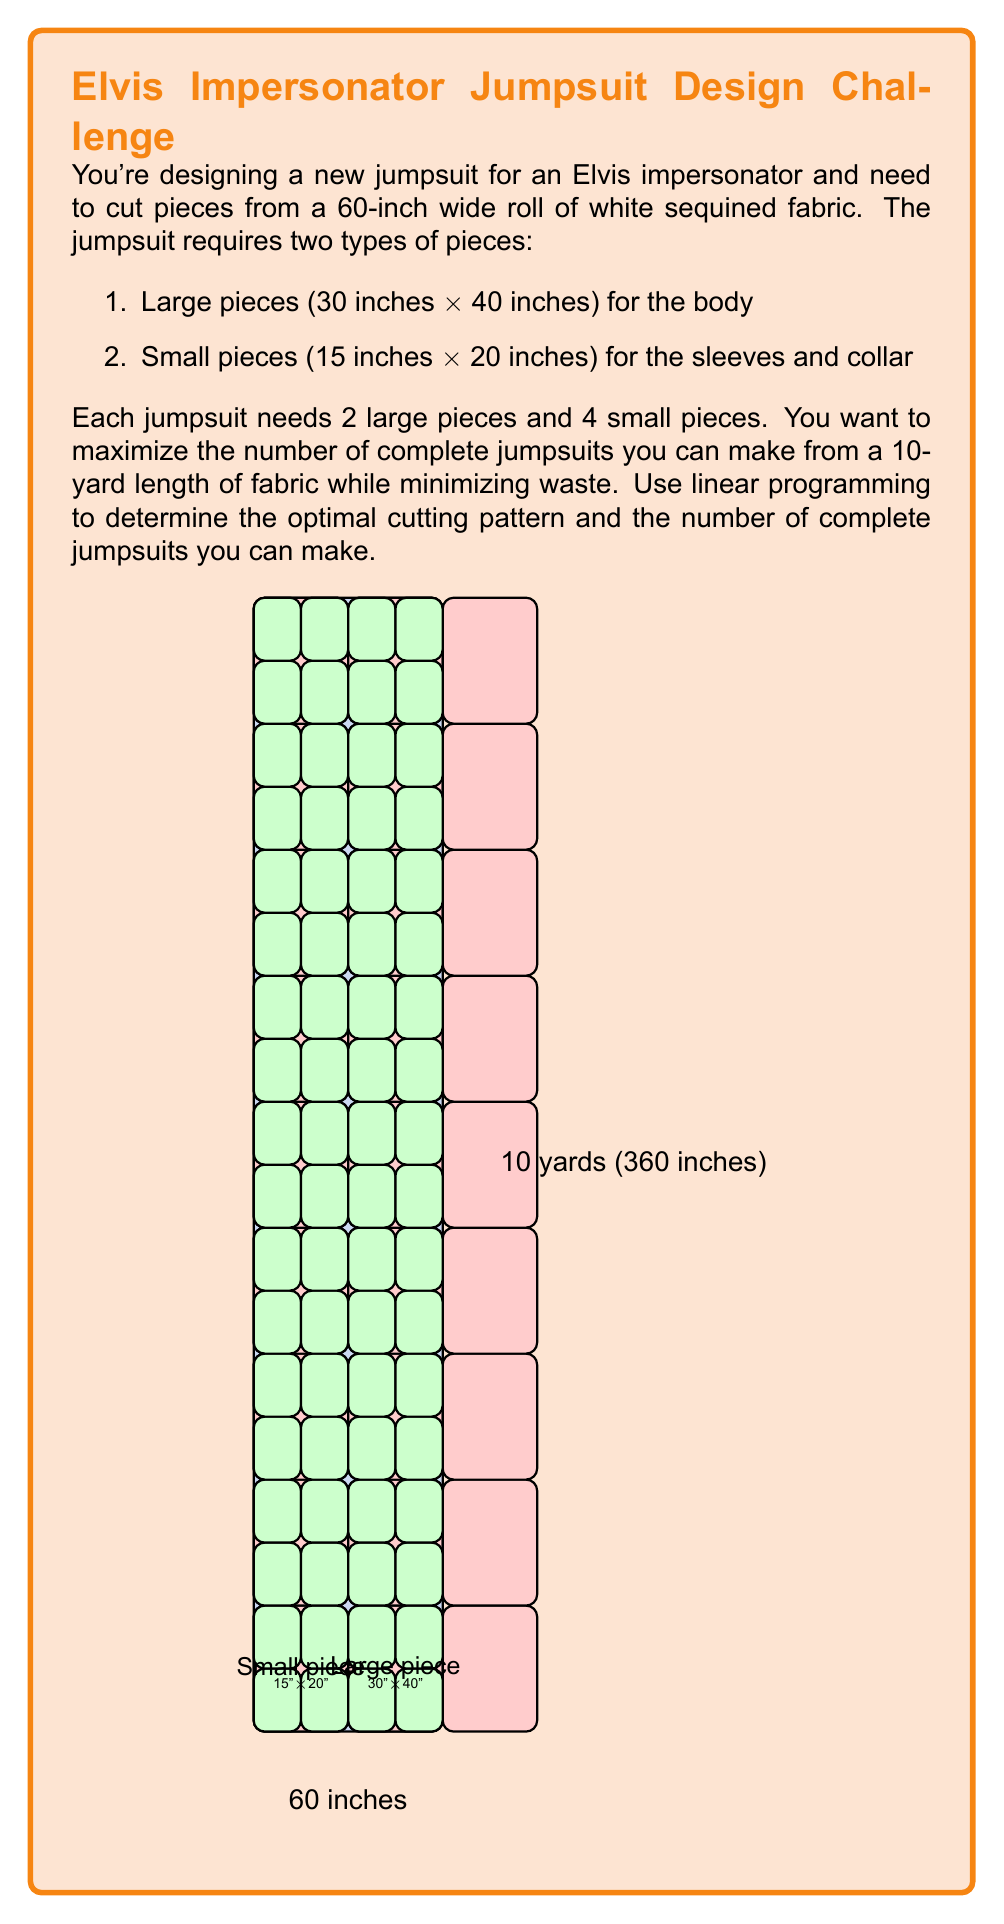Help me with this question. Let's approach this step-by-step using linear programming:

1) Define variables:
   Let $x$ = number of large pieces cut
   Let $y$ = number of small pieces cut

2) Objective function:
   We want to maximize the number of complete jumpsuits. Each jumpsuit needs 2 large pieces and 4 small pieces.
   Maximize $Z = \min(\frac{x}{2}, \frac{y}{4})$

3) Constraints:
   a) Area constraint: Total area of cut pieces ≤ Total fabric area
      $$(30 \times 40)x + (15 \times 20)y \leq 60 \times 360$$
      $$1200x + 300y \leq 21600$$
   
   b) Width constraint: We can cut at most 2 large pieces or 4 small pieces across the width
      $$30x + 15y \leq 60 \times 6 = 360$$ (multiplied by 6 to match the scale of the area constraint)

4) Non-negativity constraints:
   $$x \geq 0, y \geq 0$$

5) To solve this, we need to transform our objective function:
   Let $Z = \min(\frac{x}{2}, \frac{y}{4})$
   This is equivalent to:
   Maximize $Z$ subject to:
   $$Z \leq \frac{x}{2}$$ and $$Z \leq \frac{y}{4}$$

6) Solve the linear program:
   Maximize $Z$ subject to:
   $$1200x + 300y \leq 21600$$
   $$30x + 15y \leq 360$$
   $$2Z \leq x$$
   $$4Z \leq y$$
   $$x, y, Z \geq 0$$

7) Solving this (using a linear programming solver) gives:
   $x = 18, y = 36, Z = 9$

8) This means we can cut 18 large pieces and 36 small pieces, making 9 complete jumpsuits.

9) To verify:
   18 large pieces = 9 jumpsuits × 2 large pieces per jumpsuit
   36 small pieces = 9 jumpsuits × 4 small pieces per jumpsuit

The cutting pattern uses all the fabric width (2 large pieces or 4 small pieces across) and exactly 10 yards of length (9 rows of large pieces).
Answer: 9 jumpsuits 